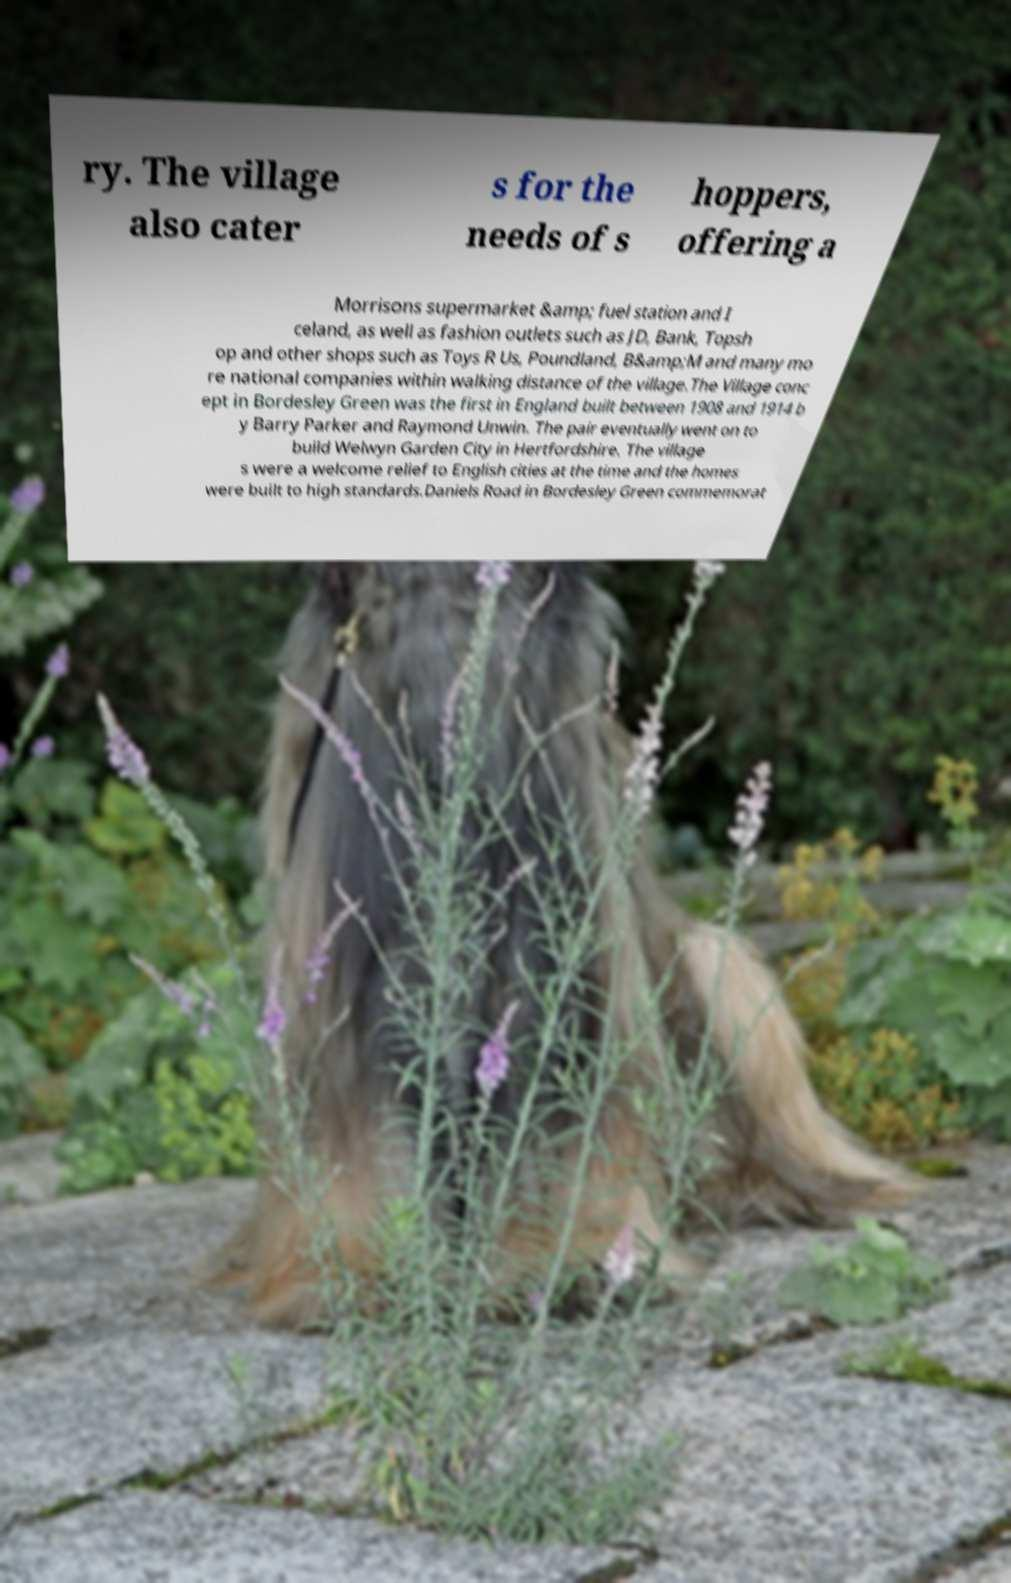Could you extract and type out the text from this image? ry. The village also cater s for the needs of s hoppers, offering a Morrisons supermarket &amp; fuel station and I celand, as well as fashion outlets such as JD, Bank, Topsh op and other shops such as Toys R Us, Poundland, B&amp;M and many mo re national companies within walking distance of the village.The Village conc ept in Bordesley Green was the first in England built between 1908 and 1914 b y Barry Parker and Raymond Unwin. The pair eventually went on to build Welwyn Garden City in Hertfordshire. The village s were a welcome relief to English cities at the time and the homes were built to high standards.Daniels Road in Bordesley Green commemorat 